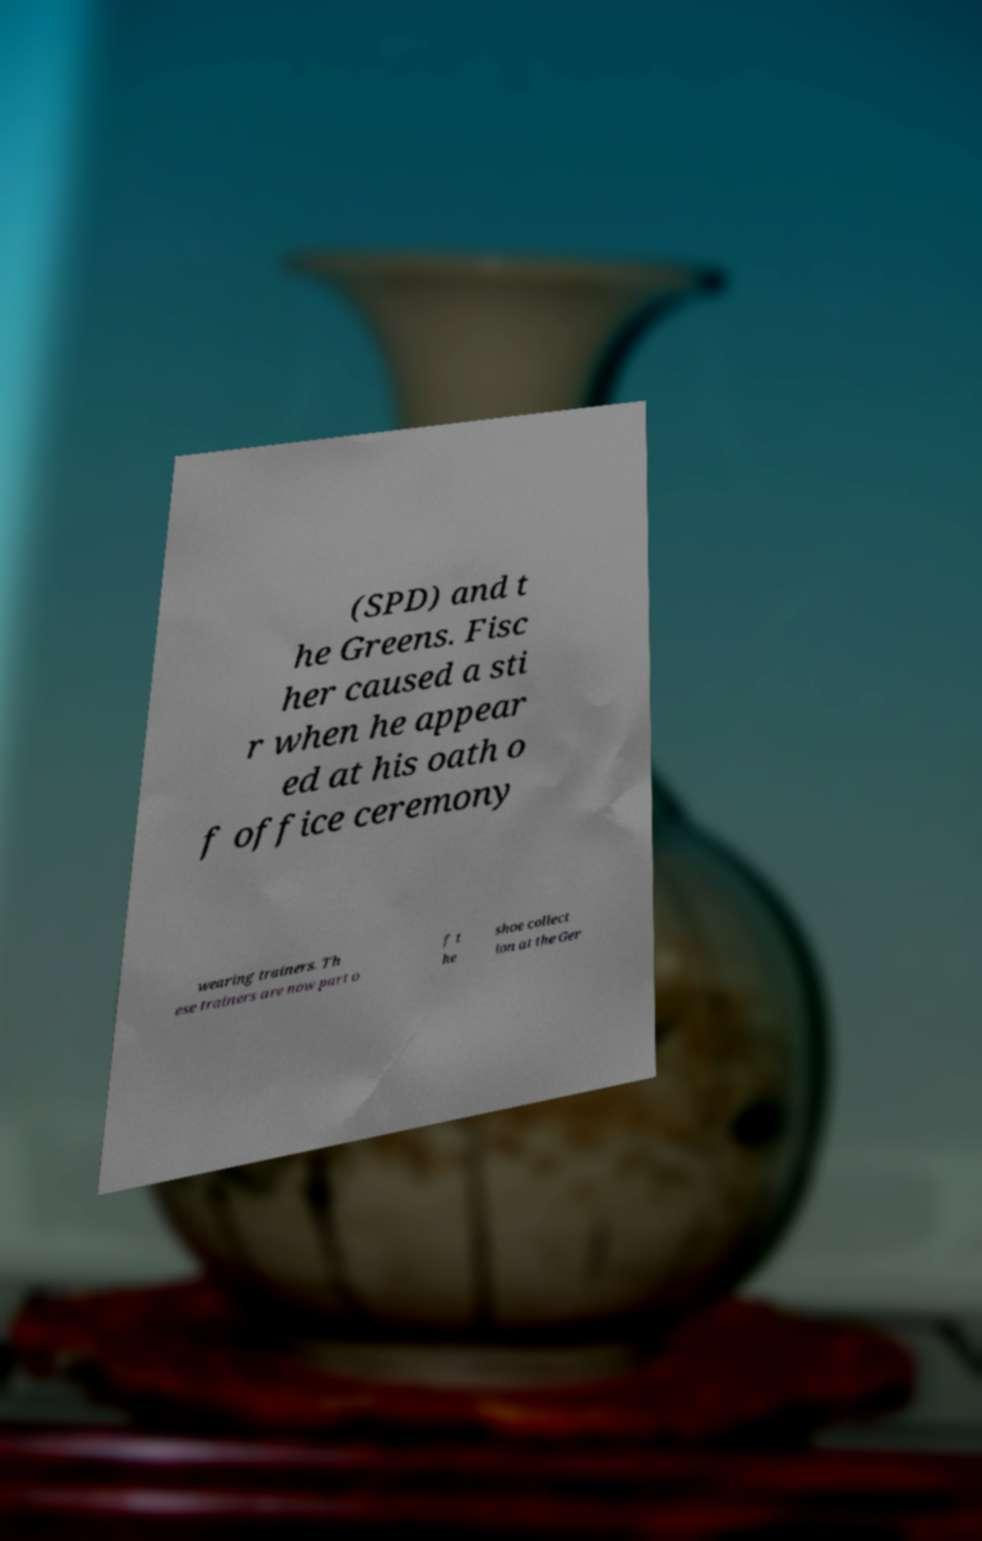What messages or text are displayed in this image? I need them in a readable, typed format. (SPD) and t he Greens. Fisc her caused a sti r when he appear ed at his oath o f office ceremony wearing trainers. Th ese trainers are now part o f t he shoe collect ion at the Ger 